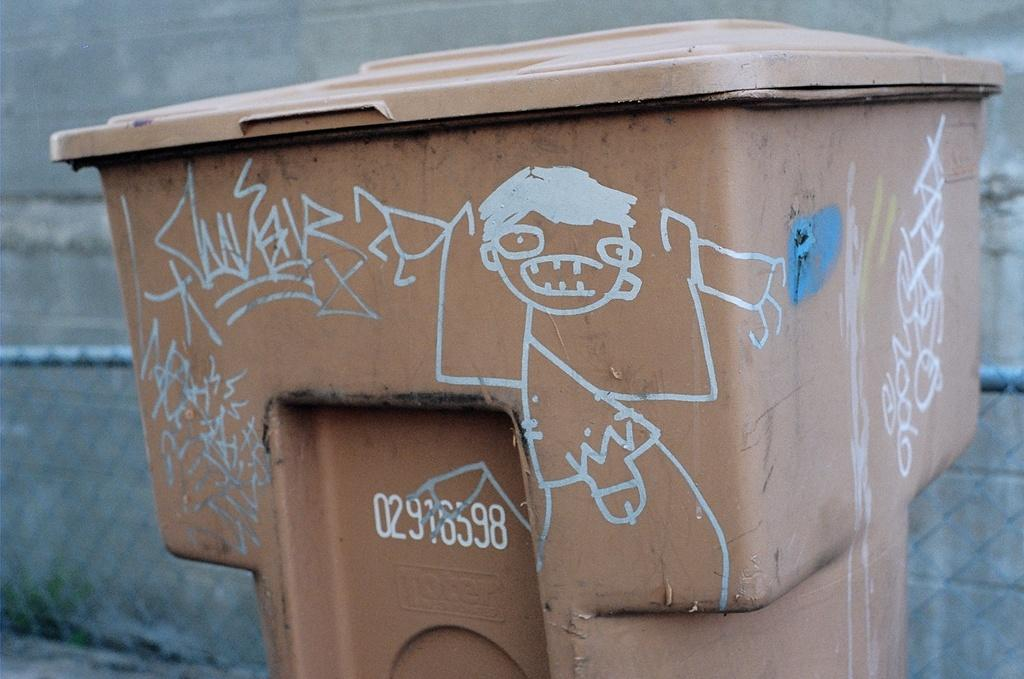<image>
Render a clear and concise summary of the photo. Brown garbage can with a cartoon character and the numbers 02976598 on it. 